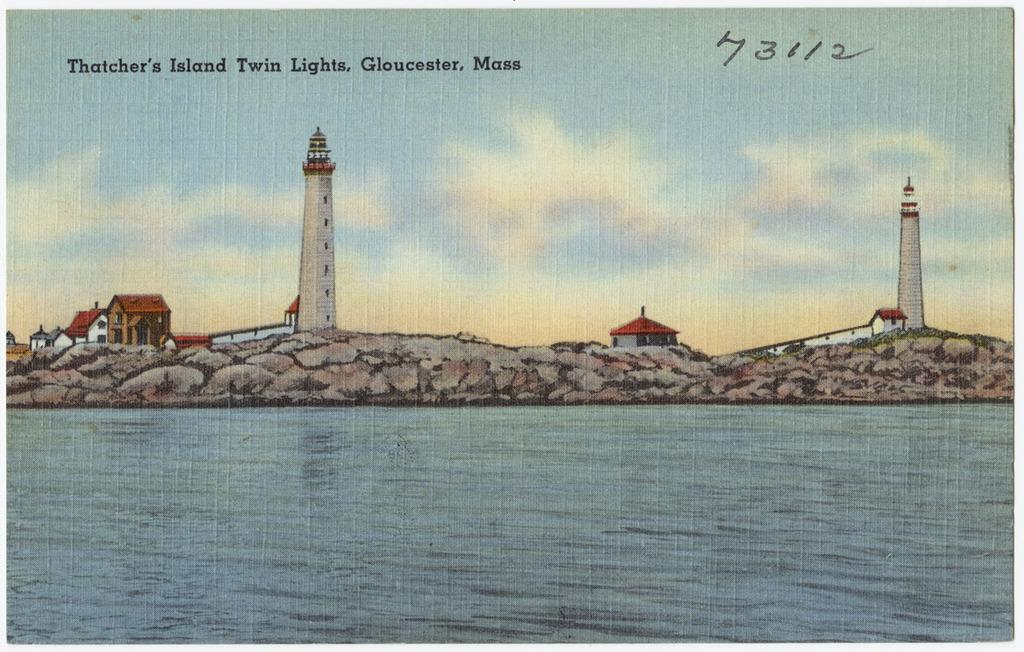What is the main subject of the paper in the image? The paper contains a depiction of the sky, clouds, buildings, water, grass, a tower, a wall, and a roof. What is the purpose of the paper in the image? There is something written on the paper, which suggests it might be a note or a message. Can you describe the various elements depicted on the paper? The paper contains depictions of the sky, clouds, buildings, water, grass, a tower, a wall, and a roof. What type of veil can be seen covering the side of the tower in the image? There is no veil present in the image, nor is there a tower with a side that could be covered by a veil. 